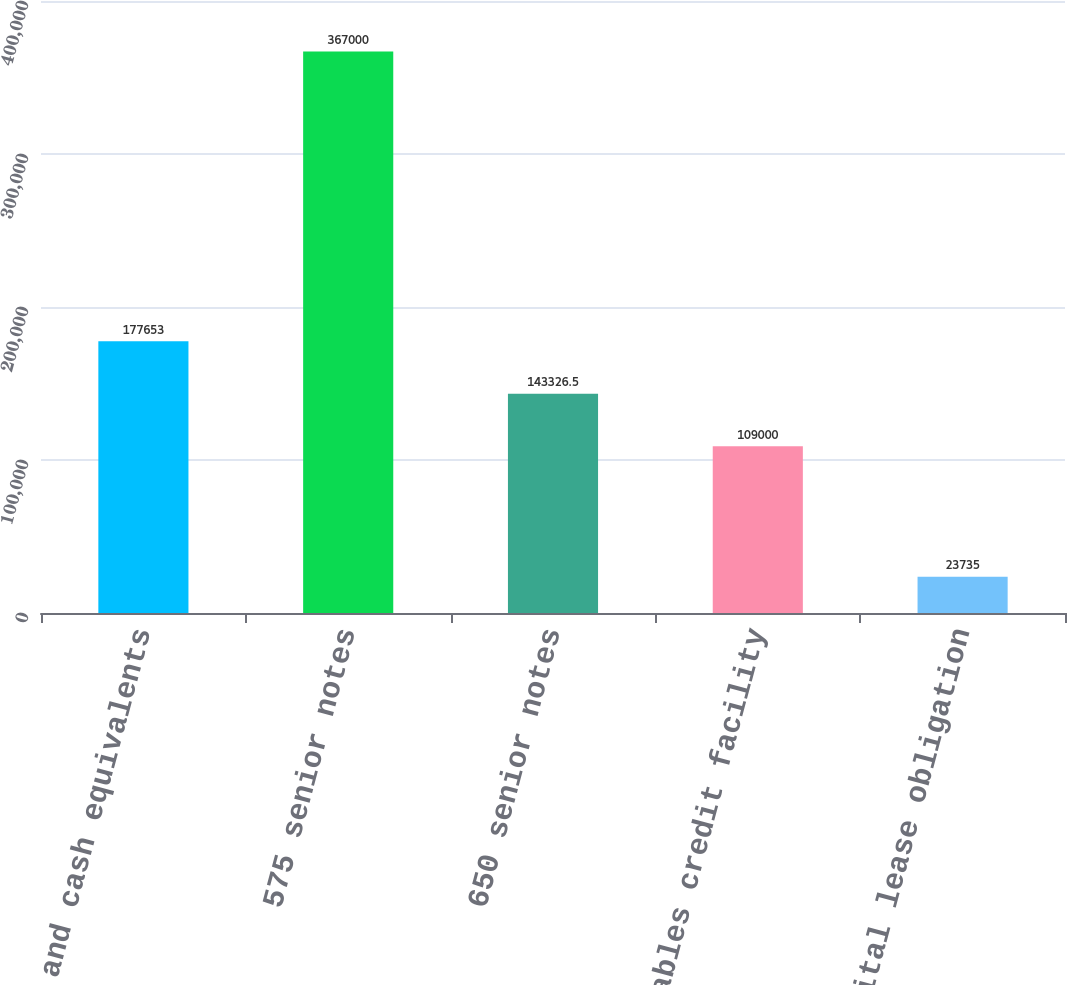Convert chart. <chart><loc_0><loc_0><loc_500><loc_500><bar_chart><fcel>Cash and cash equivalents<fcel>575 senior notes<fcel>650 senior notes<fcel>Receivables credit facility<fcel>Capital lease obligation<nl><fcel>177653<fcel>367000<fcel>143326<fcel>109000<fcel>23735<nl></chart> 